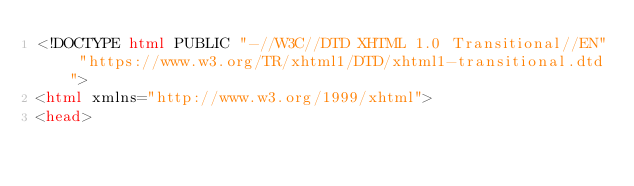<code> <loc_0><loc_0><loc_500><loc_500><_HTML_><!DOCTYPE html PUBLIC "-//W3C//DTD XHTML 1.0 Transitional//EN" "https://www.w3.org/TR/xhtml1/DTD/xhtml1-transitional.dtd">
<html xmlns="http://www.w3.org/1999/xhtml">
<head></code> 